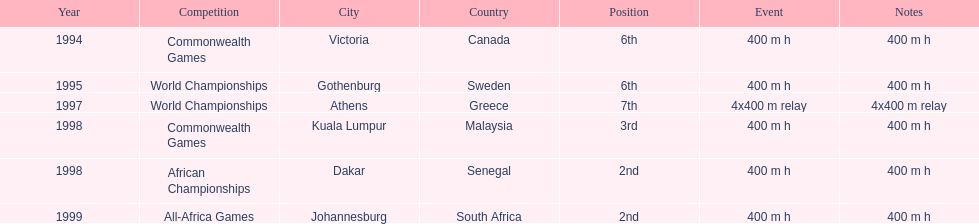What is the number of titles ken harden has one 6. 